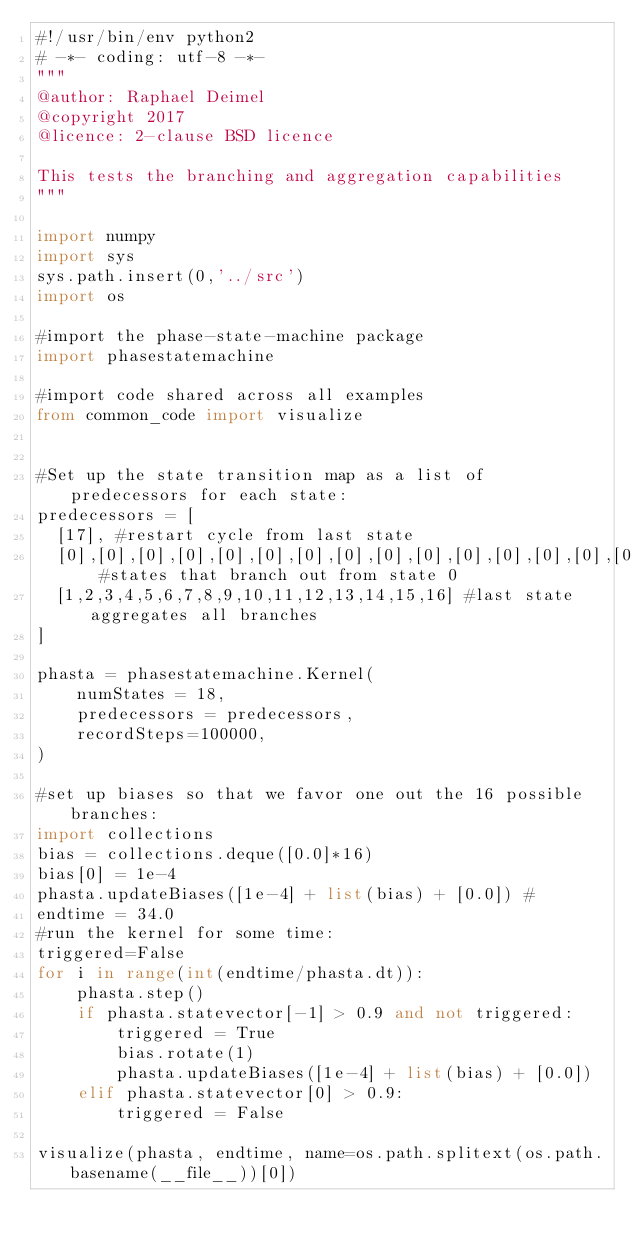Convert code to text. <code><loc_0><loc_0><loc_500><loc_500><_Python_>#!/usr/bin/env python2
# -*- coding: utf-8 -*-
"""
@author: Raphael Deimel
@copyright 2017
@licence: 2-clause BSD licence

This tests the branching and aggregation capabilities
"""

import numpy
import sys
sys.path.insert(0,'../src')
import os

#import the phase-state-machine package
import phasestatemachine 

#import code shared across all examples
from common_code import visualize


#Set up the state transition map as a list of predecessors for each state:
predecessors = [
  [17], #restart cycle from last state
  [0],[0],[0],[0],[0],[0],[0],[0],[0],[0],[0],[0],[0],[0],[0],[0], #states that branch out from state 0
  [1,2,3,4,5,6,7,8,9,10,11,12,13,14,15,16] #last state aggregates all branches
]

phasta = phasestatemachine.Kernel(
    numStates = 18,
    predecessors = predecessors, 
    recordSteps=100000,
)

#set up biases so that we favor one out the 16 possible branches:
import collections
bias = collections.deque([0.0]*16)
bias[0] = 1e-4
phasta.updateBiases([1e-4] + list(bias) + [0.0]) #
endtime = 34.0
#run the kernel for some time:
triggered=False
for i in range(int(endtime/phasta.dt)):
    phasta.step()
    if phasta.statevector[-1] > 0.9 and not triggered:
        triggered = True
        bias.rotate(1)
        phasta.updateBiases([1e-4] + list(bias) + [0.0])
    elif phasta.statevector[0] > 0.9:
        triggered = False

visualize(phasta, endtime, name=os.path.splitext(os.path.basename(__file__))[0])
</code> 